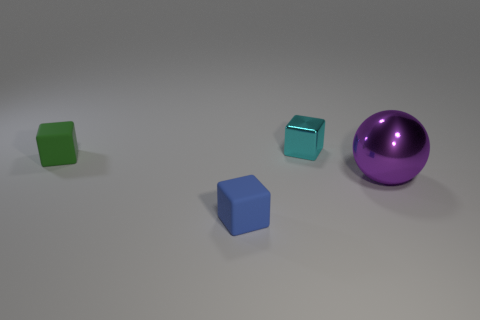Add 2 big things. How many objects exist? 6 Subtract all spheres. How many objects are left? 3 Subtract all tiny cyan blocks. Subtract all tiny cubes. How many objects are left? 0 Add 2 cyan metal blocks. How many cyan metal blocks are left? 3 Add 3 big yellow metal cylinders. How many big yellow metal cylinders exist? 3 Subtract 0 gray cylinders. How many objects are left? 4 